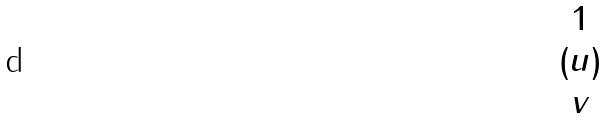<formula> <loc_0><loc_0><loc_500><loc_500>( \begin{matrix} 1 \\ u \\ v \end{matrix} )</formula> 